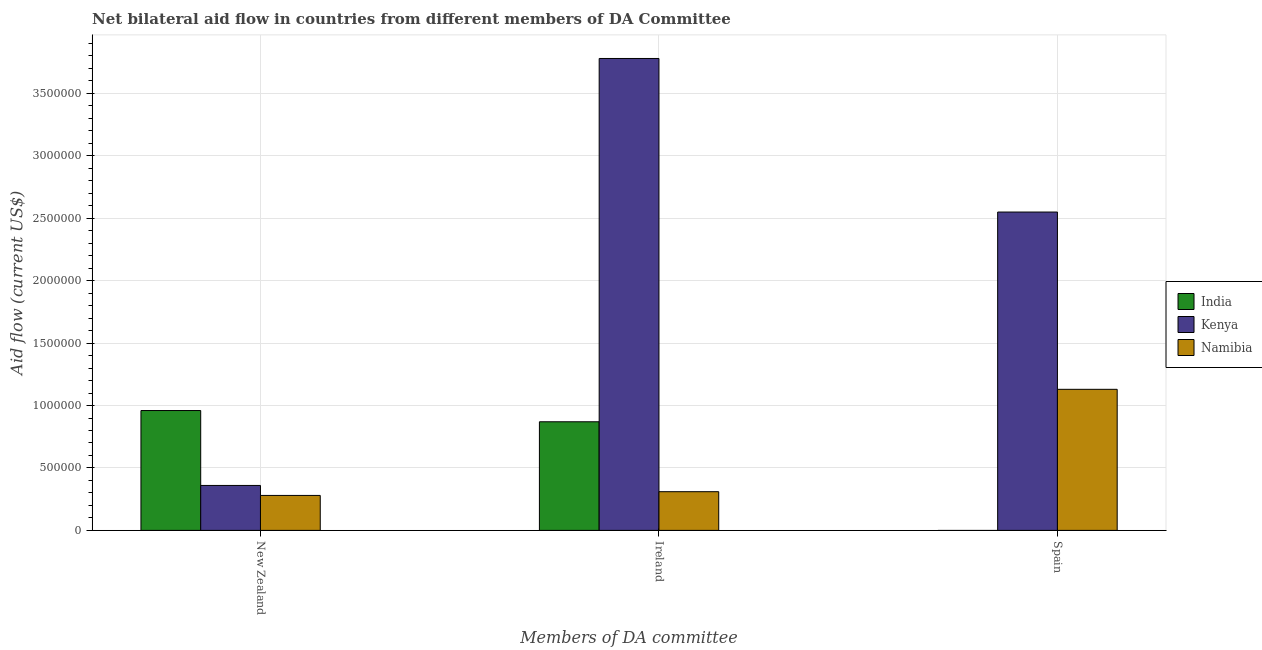Are the number of bars per tick equal to the number of legend labels?
Offer a very short reply. No. How many bars are there on the 1st tick from the left?
Keep it short and to the point. 3. How many bars are there on the 1st tick from the right?
Offer a terse response. 2. What is the label of the 1st group of bars from the left?
Your answer should be compact. New Zealand. What is the amount of aid provided by new zealand in India?
Offer a terse response. 9.60e+05. Across all countries, what is the maximum amount of aid provided by spain?
Ensure brevity in your answer.  2.55e+06. Across all countries, what is the minimum amount of aid provided by spain?
Provide a succinct answer. 0. In which country was the amount of aid provided by spain maximum?
Offer a terse response. Kenya. What is the total amount of aid provided by spain in the graph?
Keep it short and to the point. 3.68e+06. What is the difference between the amount of aid provided by ireland in Namibia and that in Kenya?
Give a very brief answer. -3.47e+06. What is the difference between the amount of aid provided by spain in India and the amount of aid provided by ireland in Namibia?
Your response must be concise. -3.10e+05. What is the average amount of aid provided by ireland per country?
Keep it short and to the point. 1.65e+06. What is the difference between the amount of aid provided by ireland and amount of aid provided by new zealand in Kenya?
Provide a short and direct response. 3.42e+06. In how many countries, is the amount of aid provided by spain greater than 900000 US$?
Provide a succinct answer. 2. What is the ratio of the amount of aid provided by new zealand in Namibia to that in Kenya?
Your answer should be compact. 0.78. Is the amount of aid provided by spain in Namibia less than that in Kenya?
Offer a terse response. Yes. What is the difference between the highest and the second highest amount of aid provided by new zealand?
Offer a terse response. 6.00e+05. What is the difference between the highest and the lowest amount of aid provided by spain?
Make the answer very short. 2.55e+06. Is the sum of the amount of aid provided by new zealand in India and Namibia greater than the maximum amount of aid provided by ireland across all countries?
Your answer should be compact. No. How many countries are there in the graph?
Provide a short and direct response. 3. Are the values on the major ticks of Y-axis written in scientific E-notation?
Offer a very short reply. No. Does the graph contain any zero values?
Make the answer very short. Yes. Does the graph contain grids?
Ensure brevity in your answer.  Yes. How many legend labels are there?
Make the answer very short. 3. What is the title of the graph?
Offer a very short reply. Net bilateral aid flow in countries from different members of DA Committee. Does "Denmark" appear as one of the legend labels in the graph?
Offer a very short reply. No. What is the label or title of the X-axis?
Give a very brief answer. Members of DA committee. What is the Aid flow (current US$) in India in New Zealand?
Offer a terse response. 9.60e+05. What is the Aid flow (current US$) of Kenya in New Zealand?
Provide a short and direct response. 3.60e+05. What is the Aid flow (current US$) of India in Ireland?
Give a very brief answer. 8.70e+05. What is the Aid flow (current US$) of Kenya in Ireland?
Your answer should be very brief. 3.78e+06. What is the Aid flow (current US$) of Namibia in Ireland?
Offer a terse response. 3.10e+05. What is the Aid flow (current US$) of Kenya in Spain?
Provide a short and direct response. 2.55e+06. What is the Aid flow (current US$) of Namibia in Spain?
Offer a terse response. 1.13e+06. Across all Members of DA committee, what is the maximum Aid flow (current US$) of India?
Make the answer very short. 9.60e+05. Across all Members of DA committee, what is the maximum Aid flow (current US$) in Kenya?
Keep it short and to the point. 3.78e+06. Across all Members of DA committee, what is the maximum Aid flow (current US$) in Namibia?
Provide a succinct answer. 1.13e+06. Across all Members of DA committee, what is the minimum Aid flow (current US$) in India?
Make the answer very short. 0. Across all Members of DA committee, what is the minimum Aid flow (current US$) in Kenya?
Your answer should be compact. 3.60e+05. Across all Members of DA committee, what is the minimum Aid flow (current US$) of Namibia?
Your response must be concise. 2.80e+05. What is the total Aid flow (current US$) in India in the graph?
Your answer should be compact. 1.83e+06. What is the total Aid flow (current US$) of Kenya in the graph?
Keep it short and to the point. 6.69e+06. What is the total Aid flow (current US$) of Namibia in the graph?
Offer a terse response. 1.72e+06. What is the difference between the Aid flow (current US$) of Kenya in New Zealand and that in Ireland?
Offer a terse response. -3.42e+06. What is the difference between the Aid flow (current US$) in Namibia in New Zealand and that in Ireland?
Give a very brief answer. -3.00e+04. What is the difference between the Aid flow (current US$) of Kenya in New Zealand and that in Spain?
Your answer should be very brief. -2.19e+06. What is the difference between the Aid flow (current US$) in Namibia in New Zealand and that in Spain?
Ensure brevity in your answer.  -8.50e+05. What is the difference between the Aid flow (current US$) of Kenya in Ireland and that in Spain?
Your answer should be very brief. 1.23e+06. What is the difference between the Aid flow (current US$) in Namibia in Ireland and that in Spain?
Provide a short and direct response. -8.20e+05. What is the difference between the Aid flow (current US$) in India in New Zealand and the Aid flow (current US$) in Kenya in Ireland?
Your answer should be very brief. -2.82e+06. What is the difference between the Aid flow (current US$) in India in New Zealand and the Aid flow (current US$) in Namibia in Ireland?
Offer a very short reply. 6.50e+05. What is the difference between the Aid flow (current US$) of India in New Zealand and the Aid flow (current US$) of Kenya in Spain?
Your answer should be very brief. -1.59e+06. What is the difference between the Aid flow (current US$) in Kenya in New Zealand and the Aid flow (current US$) in Namibia in Spain?
Make the answer very short. -7.70e+05. What is the difference between the Aid flow (current US$) of India in Ireland and the Aid flow (current US$) of Kenya in Spain?
Ensure brevity in your answer.  -1.68e+06. What is the difference between the Aid flow (current US$) of Kenya in Ireland and the Aid flow (current US$) of Namibia in Spain?
Keep it short and to the point. 2.65e+06. What is the average Aid flow (current US$) in India per Members of DA committee?
Give a very brief answer. 6.10e+05. What is the average Aid flow (current US$) of Kenya per Members of DA committee?
Keep it short and to the point. 2.23e+06. What is the average Aid flow (current US$) in Namibia per Members of DA committee?
Your answer should be compact. 5.73e+05. What is the difference between the Aid flow (current US$) in India and Aid flow (current US$) in Namibia in New Zealand?
Ensure brevity in your answer.  6.80e+05. What is the difference between the Aid flow (current US$) of Kenya and Aid flow (current US$) of Namibia in New Zealand?
Your answer should be compact. 8.00e+04. What is the difference between the Aid flow (current US$) in India and Aid flow (current US$) in Kenya in Ireland?
Provide a succinct answer. -2.91e+06. What is the difference between the Aid flow (current US$) of India and Aid flow (current US$) of Namibia in Ireland?
Offer a very short reply. 5.60e+05. What is the difference between the Aid flow (current US$) in Kenya and Aid flow (current US$) in Namibia in Ireland?
Make the answer very short. 3.47e+06. What is the difference between the Aid flow (current US$) in Kenya and Aid flow (current US$) in Namibia in Spain?
Your answer should be compact. 1.42e+06. What is the ratio of the Aid flow (current US$) in India in New Zealand to that in Ireland?
Provide a short and direct response. 1.1. What is the ratio of the Aid flow (current US$) in Kenya in New Zealand to that in Ireland?
Your answer should be compact. 0.1. What is the ratio of the Aid flow (current US$) of Namibia in New Zealand to that in Ireland?
Your response must be concise. 0.9. What is the ratio of the Aid flow (current US$) in Kenya in New Zealand to that in Spain?
Keep it short and to the point. 0.14. What is the ratio of the Aid flow (current US$) of Namibia in New Zealand to that in Spain?
Offer a terse response. 0.25. What is the ratio of the Aid flow (current US$) in Kenya in Ireland to that in Spain?
Ensure brevity in your answer.  1.48. What is the ratio of the Aid flow (current US$) of Namibia in Ireland to that in Spain?
Keep it short and to the point. 0.27. What is the difference between the highest and the second highest Aid flow (current US$) in Kenya?
Your answer should be very brief. 1.23e+06. What is the difference between the highest and the second highest Aid flow (current US$) of Namibia?
Keep it short and to the point. 8.20e+05. What is the difference between the highest and the lowest Aid flow (current US$) of India?
Give a very brief answer. 9.60e+05. What is the difference between the highest and the lowest Aid flow (current US$) of Kenya?
Offer a very short reply. 3.42e+06. What is the difference between the highest and the lowest Aid flow (current US$) of Namibia?
Your answer should be compact. 8.50e+05. 